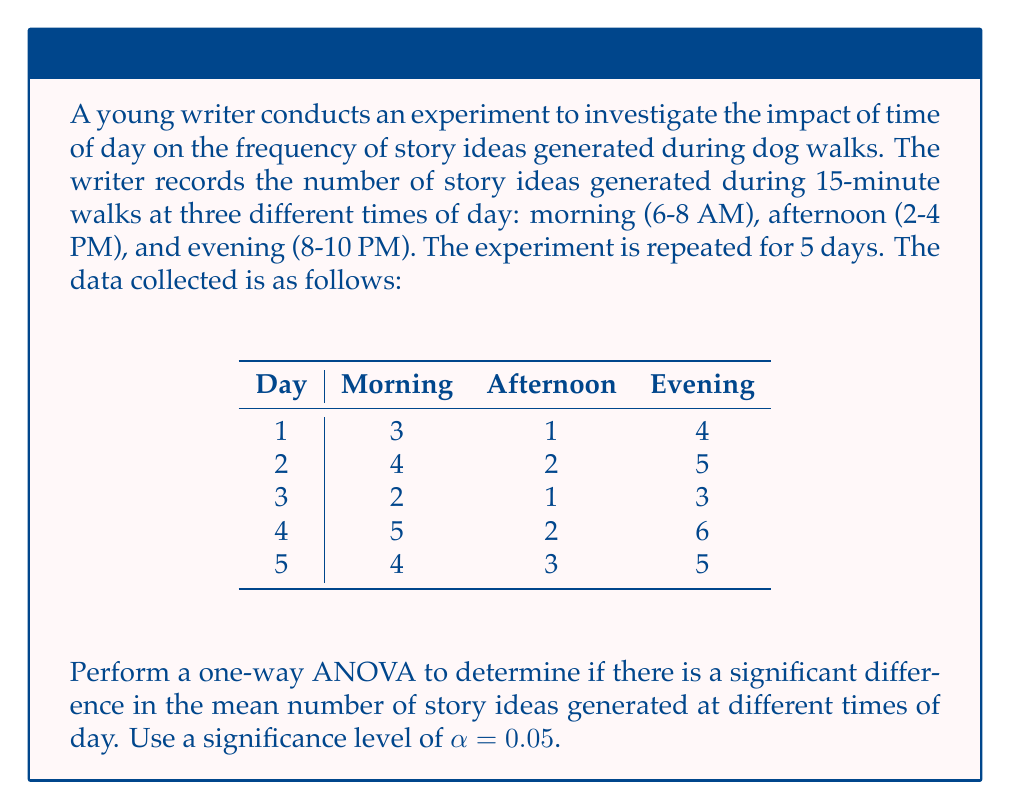Could you help me with this problem? To perform a one-way ANOVA, we need to follow these steps:

1. Calculate the sum of squares between groups (SSB), sum of squares within groups (SSW), and total sum of squares (SST).
2. Calculate the degrees of freedom for between groups (dfB) and within groups (dfW).
3. Calculate the mean square between groups (MSB) and mean square within groups (MSW).
4. Calculate the F-statistic.
5. Compare the F-statistic to the critical F-value.

Step 1: Calculate sums of squares

First, let's calculate the group means and overall mean:
Morning mean: $\bar{x}_1 = \frac{3+4+2+5+4}{5} = 3.6$
Afternoon mean: $\bar{x}_2 = \frac{1+2+1+2+3}{5} = 1.8$
Evening mean: $\bar{x}_3 = \frac{4+5+3+6+5}{5} = 4.6$
Overall mean: $\bar{x} = \frac{3.6 + 1.8 + 4.6}{3} = 3.33$

Now, we can calculate SSB, SSW, and SST:

$$\begin{align*}
SSB &= n\sum_{i=1}^k (\bar{x}_i - \bar{x})^2 \\
&= 5[(3.6 - 3.33)^2 + (1.8 - 3.33)^2 + (4.6 - 3.33)^2] \\
&= 5[0.0729 + 2.3409 + 1.6129] \\
&= 20.1335
\end{align*}$$

$$\begin{align*}
SSW &= \sum_{i=1}^k \sum_{j=1}^n (x_{ij} - \bar{x}_i)^2 \\
&= [(3-3.6)^2 + (4-3.6)^2 + (2-3.6)^2 + (5-3.6)^2 + (4-3.6)^2] \\
&+ [(1-1.8)^2 + (2-1.8)^2 + (1-1.8)^2 + (2-1.8)^2 + (3-1.8)^2] \\
&+ [(4-4.6)^2 + (5-4.6)^2 + (3-4.6)^2 + (6-4.6)^2 + (5-4.6)^2] \\
&= 5.2 + 2.8 + 5.2 \\
&= 13.2
\end{align*}$$

$$SST = SSB + SSW = 20.1335 + 13.2 = 33.3335$$

Step 2: Calculate degrees of freedom

$$\begin{align*}
dfB &= k - 1 = 3 - 1 = 2 \\
dfW &= N - k = 15 - 3 = 12 \\
dfT &= N - 1 = 15 - 1 = 14
\end{align*}$$

Step 3: Calculate mean squares

$$\begin{align*}
MSB &= \frac{SSB}{dfB} = \frac{20.1335}{2} = 10.06675 \\
MSW &= \frac{SSW}{dfW} = \frac{13.2}{12} = 1.1
\end{align*}$$

Step 4: Calculate F-statistic

$$F = \frac{MSB}{MSW} = \frac{10.06675}{1.1} = 9.15159$$

Step 5: Compare F-statistic to critical F-value

The critical F-value for $\alpha = 0.05$, $dfB = 2$, and $dfW = 12$ is approximately 3.89. Since our calculated F-statistic (9.15159) is greater than the critical F-value (3.89), we reject the null hypothesis.
Answer: The one-way ANOVA results show a significant difference in the mean number of story ideas generated at different times of day (F(2, 12) = 9.15, p < 0.05). We reject the null hypothesis and conclude that the time of day has a significant impact on the frequency of story ideas generated during dog walks. 